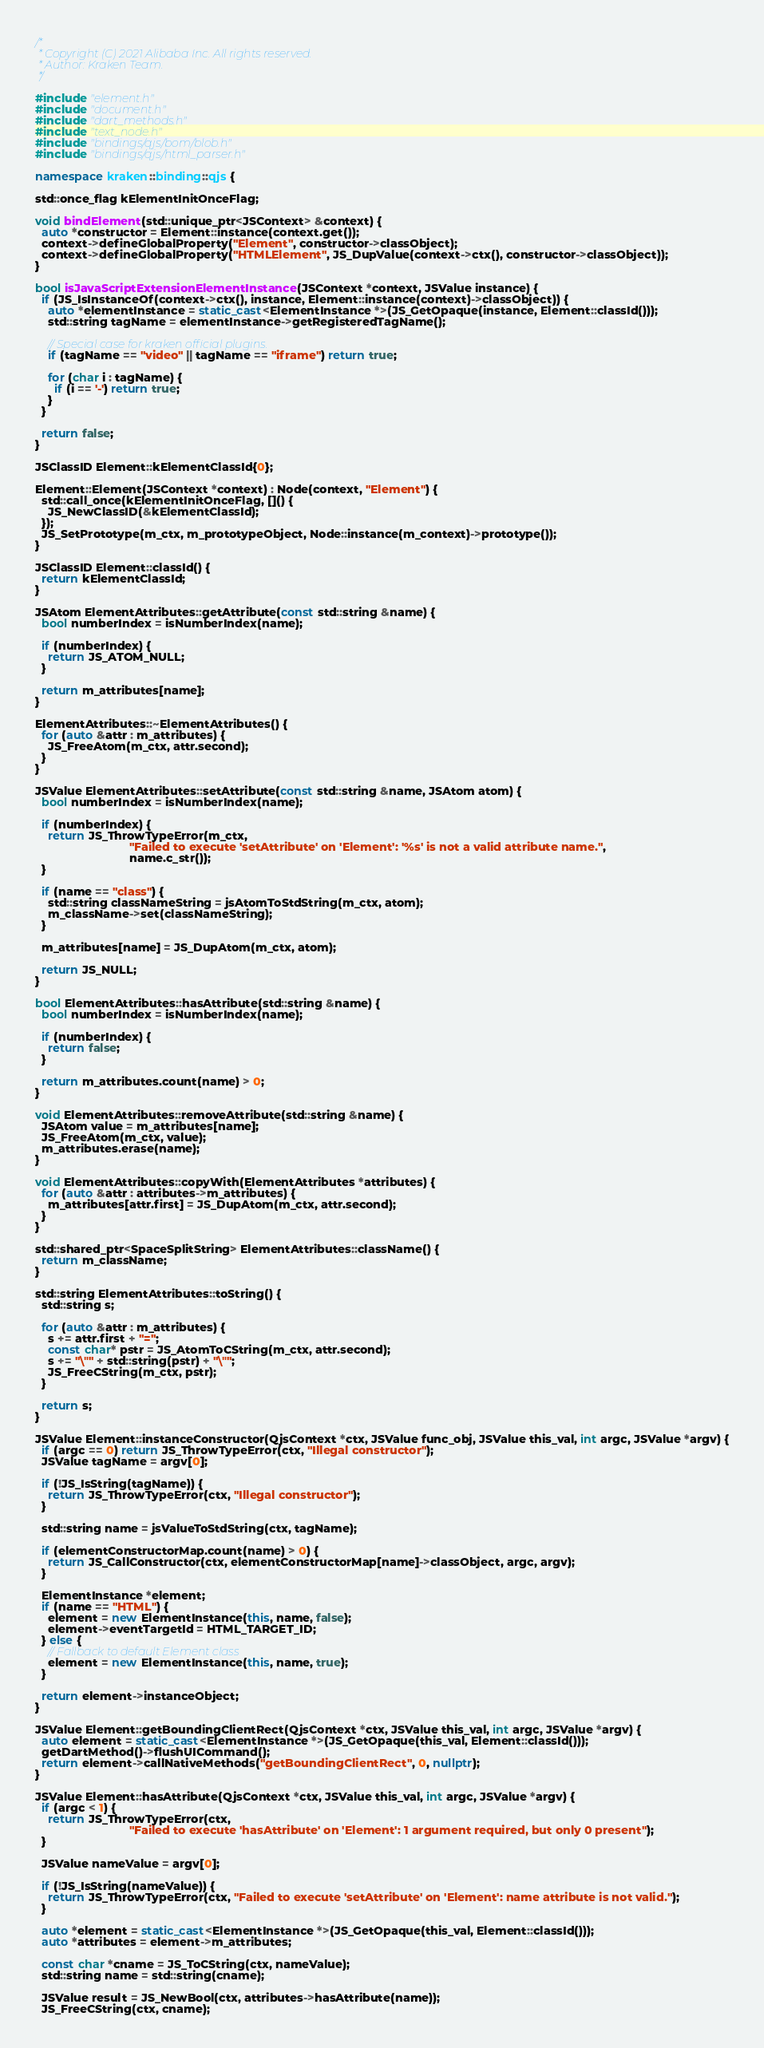Convert code to text. <code><loc_0><loc_0><loc_500><loc_500><_C++_>/*
 * Copyright (C) 2021 Alibaba Inc. All rights reserved.
 * Author: Kraken Team.
 */

#include "element.h"
#include "document.h"
#include "dart_methods.h"
#include "text_node.h"
#include "bindings/qjs/bom/blob.h"
#include "bindings/qjs/html_parser.h"

namespace kraken::binding::qjs {

std::once_flag kElementInitOnceFlag;

void bindElement(std::unique_ptr<JSContext> &context) {
  auto *constructor = Element::instance(context.get());
  context->defineGlobalProperty("Element", constructor->classObject);
  context->defineGlobalProperty("HTMLElement", JS_DupValue(context->ctx(), constructor->classObject));
}

bool isJavaScriptExtensionElementInstance(JSContext *context, JSValue instance) {
  if (JS_IsInstanceOf(context->ctx(), instance, Element::instance(context)->classObject)) {
    auto *elementInstance = static_cast<ElementInstance *>(JS_GetOpaque(instance, Element::classId()));
    std::string tagName = elementInstance->getRegisteredTagName();

    // Special case for kraken official plugins.
    if (tagName == "video" || tagName == "iframe") return true;

    for (char i : tagName) {
      if (i == '-') return true;
    }
  }

  return false;
}

JSClassID Element::kElementClassId{0};

Element::Element(JSContext *context) : Node(context, "Element") {
  std::call_once(kElementInitOnceFlag, []() {
    JS_NewClassID(&kElementClassId);
  });
  JS_SetPrototype(m_ctx, m_prototypeObject, Node::instance(m_context)->prototype());
}

JSClassID Element::classId() {
  return kElementClassId;
}

JSAtom ElementAttributes::getAttribute(const std::string &name) {
  bool numberIndex = isNumberIndex(name);

  if (numberIndex) {
    return JS_ATOM_NULL;
  }

  return m_attributes[name];
}

ElementAttributes::~ElementAttributes() {
  for (auto &attr : m_attributes) {
    JS_FreeAtom(m_ctx, attr.second);
  }
}

JSValue ElementAttributes::setAttribute(const std::string &name, JSAtom atom) {
  bool numberIndex = isNumberIndex(name);

  if (numberIndex) {
    return JS_ThrowTypeError(m_ctx,
                             "Failed to execute 'setAttribute' on 'Element': '%s' is not a valid attribute name.",
                             name.c_str());
  }

  if (name == "class") {
    std::string classNameString = jsAtomToStdString(m_ctx, atom);
    m_className->set(classNameString);
  }

  m_attributes[name] = JS_DupAtom(m_ctx, atom);

  return JS_NULL;
}

bool ElementAttributes::hasAttribute(std::string &name) {
  bool numberIndex = isNumberIndex(name);

  if (numberIndex) {
    return false;
  }

  return m_attributes.count(name) > 0;
}

void ElementAttributes::removeAttribute(std::string &name) {
  JSAtom value = m_attributes[name];
  JS_FreeAtom(m_ctx, value);
  m_attributes.erase(name);
}

void ElementAttributes::copyWith(ElementAttributes *attributes) {
  for (auto &attr : attributes->m_attributes) {
    m_attributes[attr.first] = JS_DupAtom(m_ctx, attr.second);
  }
}

std::shared_ptr<SpaceSplitString> ElementAttributes::className() {
  return m_className;
}

std::string ElementAttributes::toString() {
  std::string s;

  for (auto &attr : m_attributes) {
    s += attr.first + "=";
    const char* pstr = JS_AtomToCString(m_ctx, attr.second);
    s += "\"" + std::string(pstr) + "\"";
    JS_FreeCString(m_ctx, pstr);
  }

  return s;
}

JSValue Element::instanceConstructor(QjsContext *ctx, JSValue func_obj, JSValue this_val, int argc, JSValue *argv) {
  if (argc == 0) return JS_ThrowTypeError(ctx, "Illegal constructor");
  JSValue tagName = argv[0];

  if (!JS_IsString(tagName)) {
    return JS_ThrowTypeError(ctx, "Illegal constructor");
  }

  std::string name = jsValueToStdString(ctx, tagName);

  if (elementConstructorMap.count(name) > 0) {
    return JS_CallConstructor(ctx, elementConstructorMap[name]->classObject, argc, argv);
  }

  ElementInstance *element;
  if (name == "HTML") {
    element = new ElementInstance(this, name, false);
    element->eventTargetId = HTML_TARGET_ID;
  } else {
    // Fallback to default Element class
    element = new ElementInstance(this, name, true);
  }

  return element->instanceObject;
}

JSValue Element::getBoundingClientRect(QjsContext *ctx, JSValue this_val, int argc, JSValue *argv) {
  auto element = static_cast<ElementInstance *>(JS_GetOpaque(this_val, Element::classId()));
  getDartMethod()->flushUICommand();
  return element->callNativeMethods("getBoundingClientRect", 0, nullptr);
}

JSValue Element::hasAttribute(QjsContext *ctx, JSValue this_val, int argc, JSValue *argv) {
  if (argc < 1) {
    return JS_ThrowTypeError(ctx,
                             "Failed to execute 'hasAttribute' on 'Element': 1 argument required, but only 0 present");
  }

  JSValue nameValue = argv[0];

  if (!JS_IsString(nameValue)) {
    return JS_ThrowTypeError(ctx, "Failed to execute 'setAttribute' on 'Element': name attribute is not valid.");
  }

  auto *element = static_cast<ElementInstance *>(JS_GetOpaque(this_val, Element::classId()));
  auto *attributes = element->m_attributes;

  const char *cname = JS_ToCString(ctx, nameValue);
  std::string name = std::string(cname);

  JSValue result = JS_NewBool(ctx, attributes->hasAttribute(name));
  JS_FreeCString(ctx, cname);
</code> 